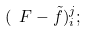<formula> <loc_0><loc_0><loc_500><loc_500>( \ F - \tilde { f } ) ^ { j } _ { i } ;</formula> 